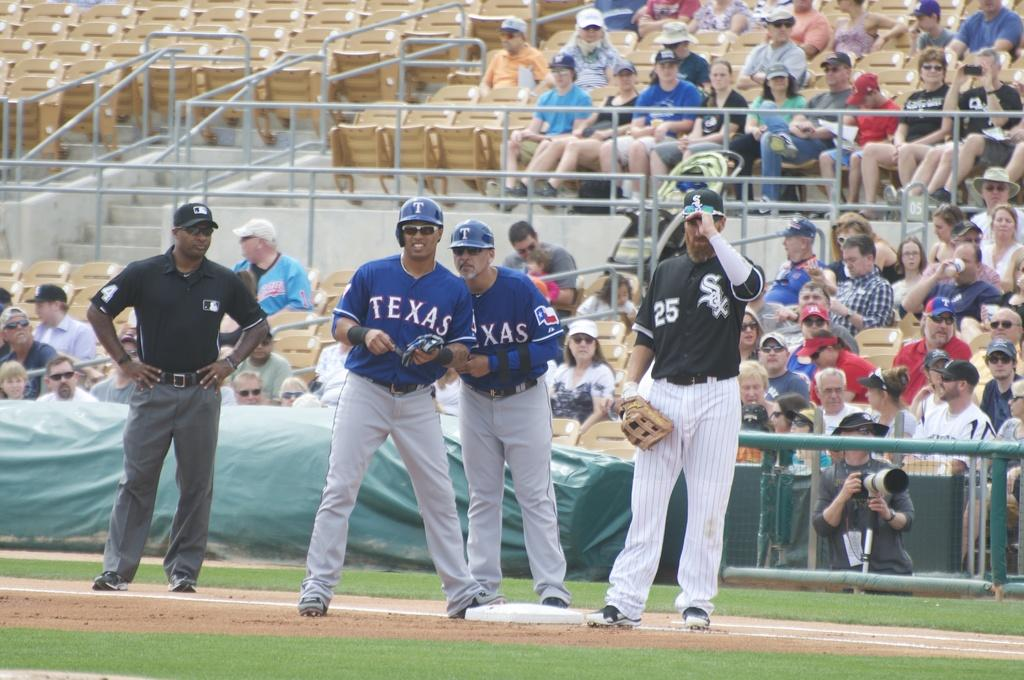<image>
Create a compact narrative representing the image presented. a Texas player is next to a White Sox player 